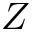<formula> <loc_0><loc_0><loc_500><loc_500>Z</formula> 